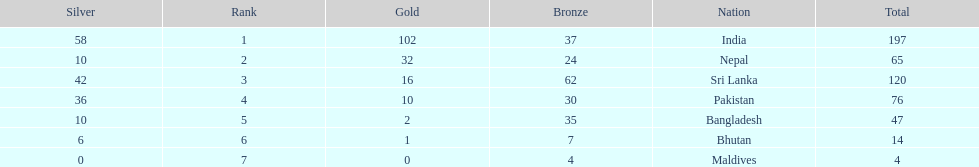What was the total number of gold medals given to all seven countries? 163. 